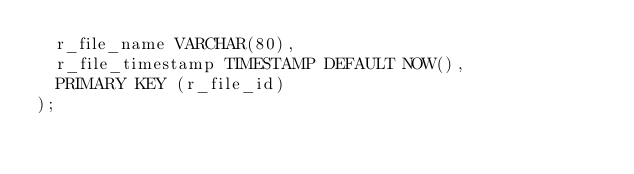<code> <loc_0><loc_0><loc_500><loc_500><_SQL_>  r_file_name VARCHAR(80),
  r_file_timestamp TIMESTAMP DEFAULT NOW(),
  PRIMARY KEY (r_file_id)
);
</code> 